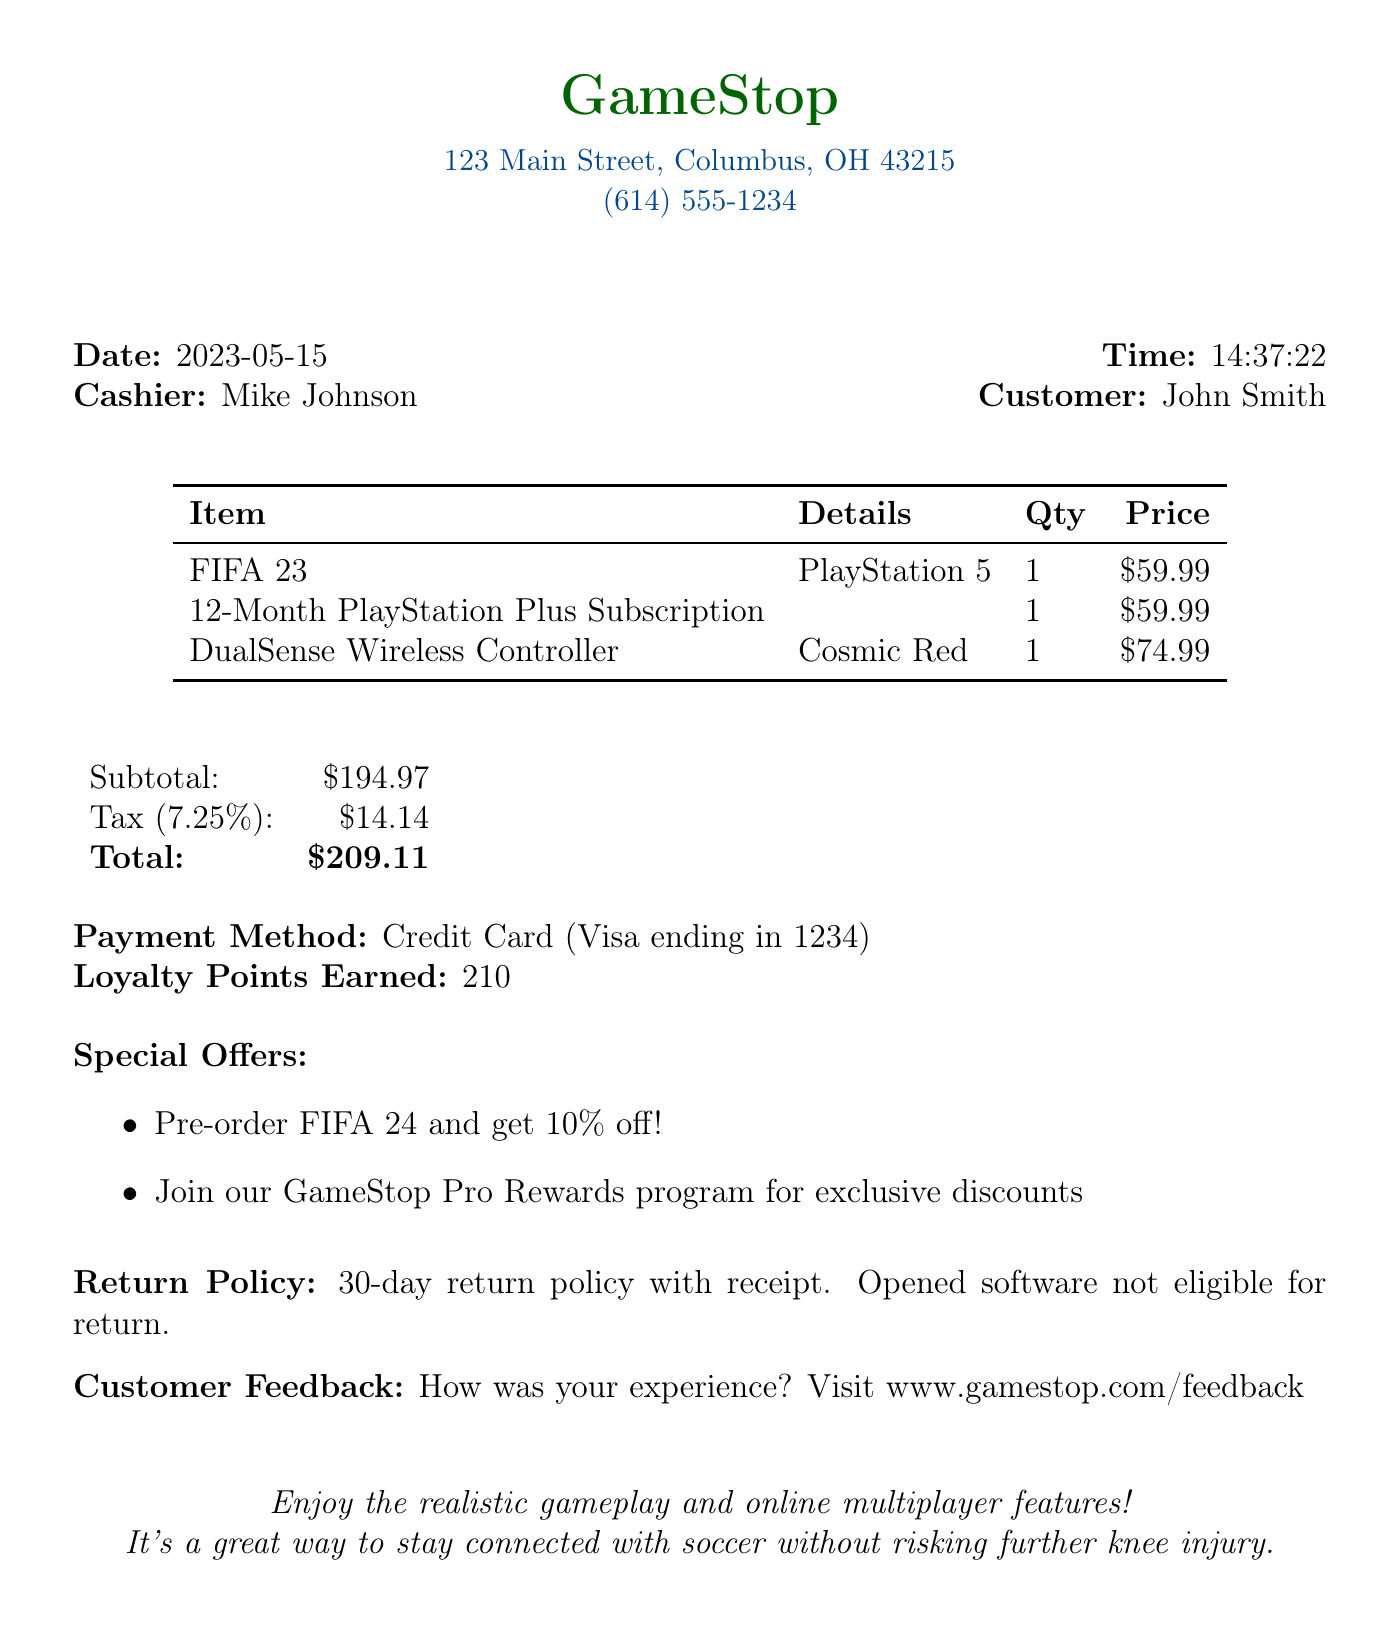What is the store name? The store name is prominently displayed at the top of the receipt.
Answer: GameStop What did the customer purchase? The items purchased are listed in the receipt including details like name and platform.
Answer: FIFA 23 What is the total amount spent? The total amount is calculated at the bottom of the receipt.
Answer: $209.11 Who was the cashier for this transaction? The cashier's name is provided in the receipt in the cashier section.
Answer: Mike Johnson What is the tax rate applied? The tax rate is mentioned adjacent to the tax amount in the subtotal area.
Answer: 7.25% How many loyalty points were earned? Loyalty points earned are listed in the payment summary.
Answer: 210 What is the return policy for the products? The return policy is described in detail within the receipt.
Answer: 30-day return policy with receipt. Opened software not eligible for return What platform is FIFA 23 available on? The platform information is listed alongside the item details in the table.
Answer: PlayStation 5 What special offer is available for FIFA 24? The special offers are clearly outlined in the designated section of the receipt.
Answer: Pre-order FIFA 24 and get 10% off! 